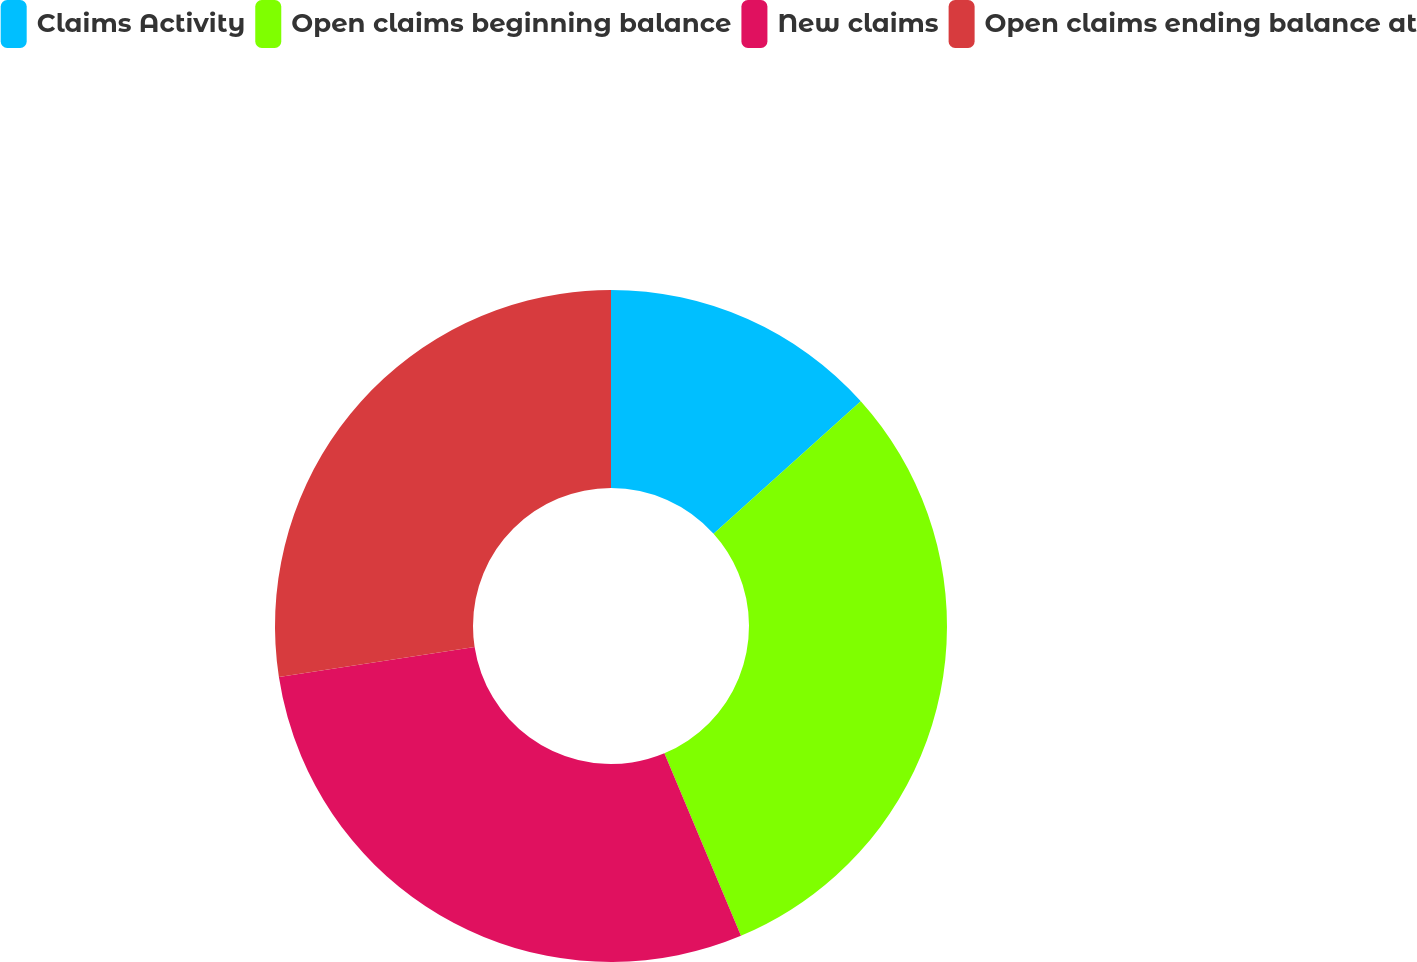Convert chart to OTSL. <chart><loc_0><loc_0><loc_500><loc_500><pie_chart><fcel>Claims Activity<fcel>Open claims beginning balance<fcel>New claims<fcel>Open claims ending balance at<nl><fcel>13.34%<fcel>30.34%<fcel>28.89%<fcel>27.43%<nl></chart> 